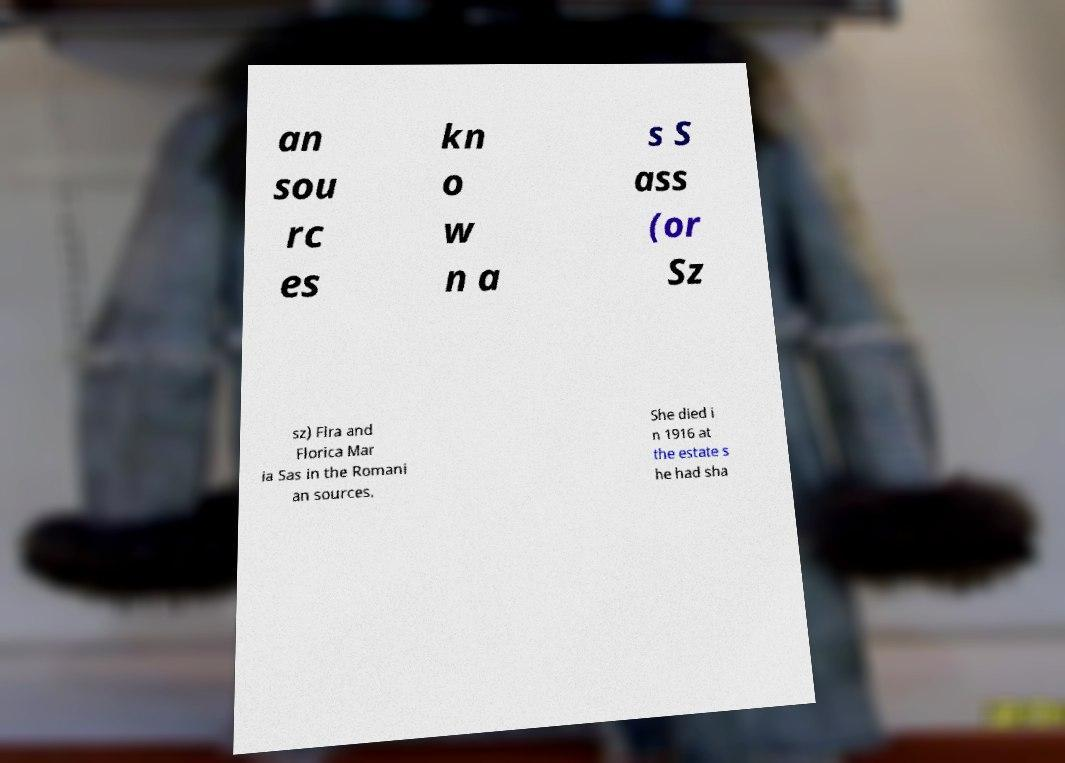Could you extract and type out the text from this image? an sou rc es kn o w n a s S ass (or Sz sz) Flra and Florica Mar ia Sas in the Romani an sources. She died i n 1916 at the estate s he had sha 